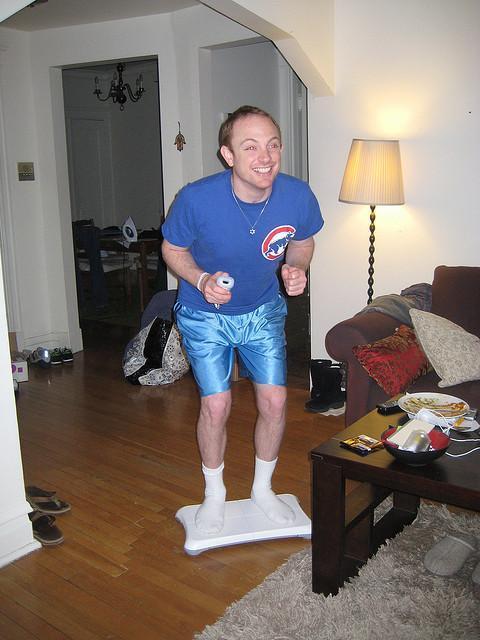How many of the umbrellas are folded?
Give a very brief answer. 0. 